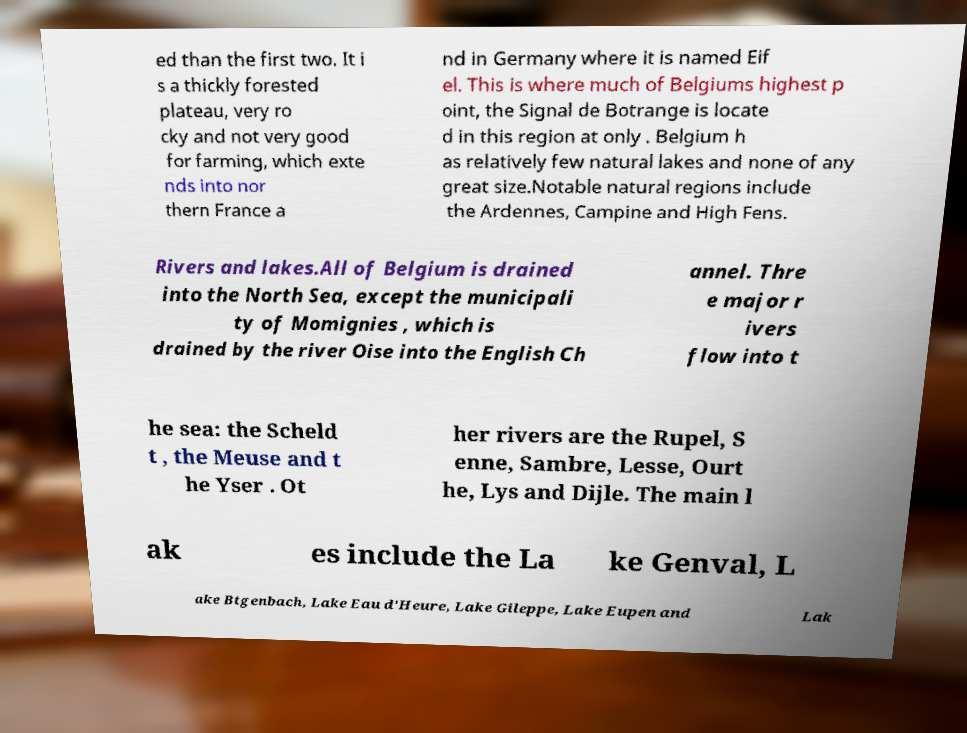For documentation purposes, I need the text within this image transcribed. Could you provide that? ed than the first two. It i s a thickly forested plateau, very ro cky and not very good for farming, which exte nds into nor thern France a nd in Germany where it is named Eif el. This is where much of Belgiums highest p oint, the Signal de Botrange is locate d in this region at only . Belgium h as relatively few natural lakes and none of any great size.Notable natural regions include the Ardennes, Campine and High Fens. Rivers and lakes.All of Belgium is drained into the North Sea, except the municipali ty of Momignies , which is drained by the river Oise into the English Ch annel. Thre e major r ivers flow into t he sea: the Scheld t , the Meuse and t he Yser . Ot her rivers are the Rupel, S enne, Sambre, Lesse, Ourt he, Lys and Dijle. The main l ak es include the La ke Genval, L ake Btgenbach, Lake Eau d'Heure, Lake Gileppe, Lake Eupen and Lak 